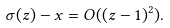<formula> <loc_0><loc_0><loc_500><loc_500>\sigma ( z ) - x = O ( ( z - 1 ) ^ { 2 } ) .</formula> 